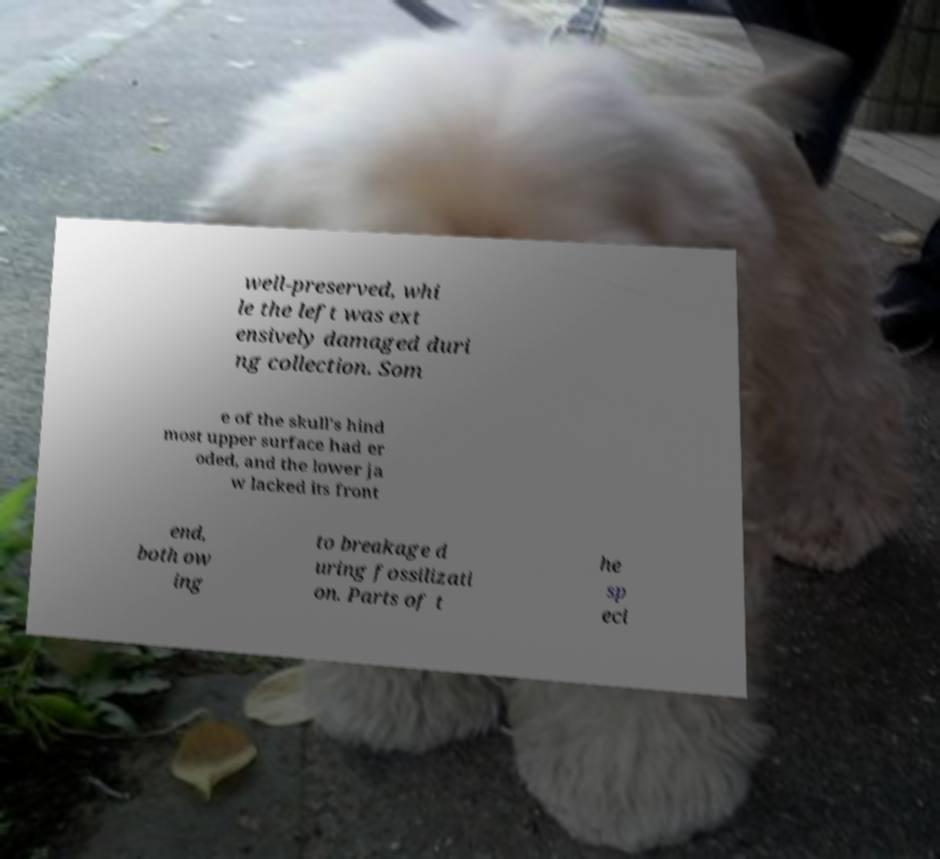For documentation purposes, I need the text within this image transcribed. Could you provide that? well-preserved, whi le the left was ext ensively damaged duri ng collection. Som e of the skull's hind most upper surface had er oded, and the lower ja w lacked its front end, both ow ing to breakage d uring fossilizati on. Parts of t he sp eci 